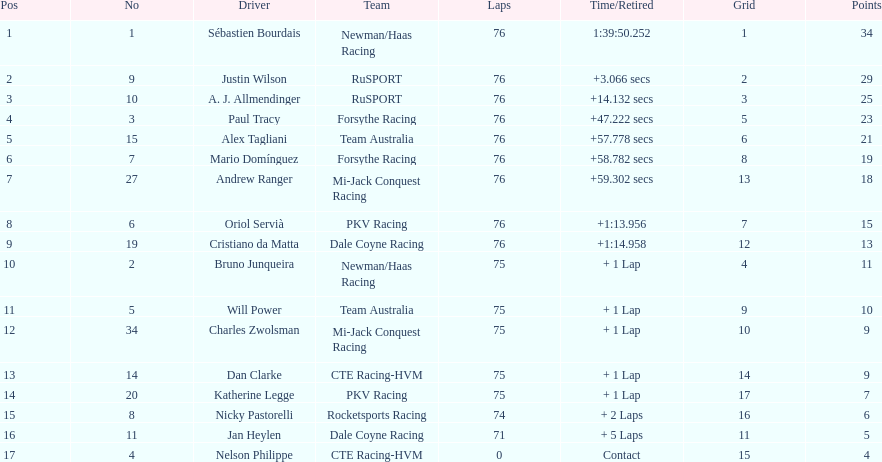Could you parse the entire table? {'header': ['Pos', 'No', 'Driver', 'Team', 'Laps', 'Time/Retired', 'Grid', 'Points'], 'rows': [['1', '1', 'Sébastien Bourdais', 'Newman/Haas Racing', '76', '1:39:50.252', '1', '34'], ['2', '9', 'Justin Wilson', 'RuSPORT', '76', '+3.066 secs', '2', '29'], ['3', '10', 'A. J. Allmendinger', 'RuSPORT', '76', '+14.132 secs', '3', '25'], ['4', '3', 'Paul Tracy', 'Forsythe Racing', '76', '+47.222 secs', '5', '23'], ['5', '15', 'Alex Tagliani', 'Team Australia', '76', '+57.778 secs', '6', '21'], ['6', '7', 'Mario Domínguez', 'Forsythe Racing', '76', '+58.782 secs', '8', '19'], ['7', '27', 'Andrew Ranger', 'Mi-Jack Conquest Racing', '76', '+59.302 secs', '13', '18'], ['8', '6', 'Oriol Servià', 'PKV Racing', '76', '+1:13.956', '7', '15'], ['9', '19', 'Cristiano da Matta', 'Dale Coyne Racing', '76', '+1:14.958', '12', '13'], ['10', '2', 'Bruno Junqueira', 'Newman/Haas Racing', '75', '+ 1 Lap', '4', '11'], ['11', '5', 'Will Power', 'Team Australia', '75', '+ 1 Lap', '9', '10'], ['12', '34', 'Charles Zwolsman', 'Mi-Jack Conquest Racing', '75', '+ 1 Lap', '10', '9'], ['13', '14', 'Dan Clarke', 'CTE Racing-HVM', '75', '+ 1 Lap', '14', '9'], ['14', '20', 'Katherine Legge', 'PKV Racing', '75', '+ 1 Lap', '17', '7'], ['15', '8', 'Nicky Pastorelli', 'Rocketsports Racing', '74', '+ 2 Laps', '16', '6'], ['16', '11', 'Jan Heylen', 'Dale Coyne Racing', '71', '+ 5 Laps', '11', '5'], ['17', '4', 'Nelson Philippe', 'CTE Racing-HVM', '0', 'Contact', '15', '4']]} What was the total points that canada earned together? 62. 